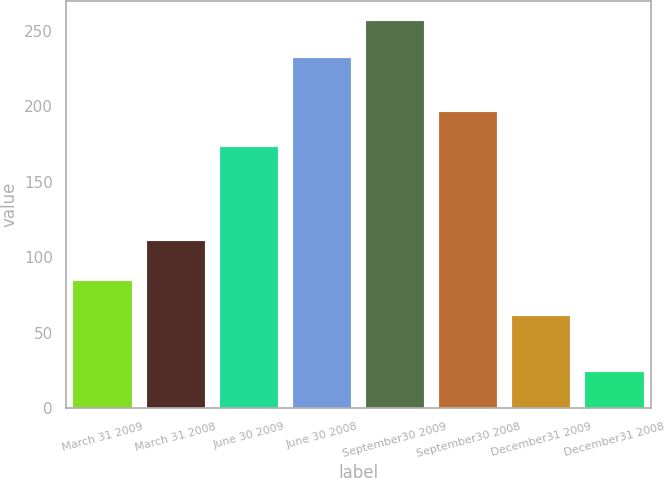Convert chart. <chart><loc_0><loc_0><loc_500><loc_500><bar_chart><fcel>March 31 2009<fcel>March 31 2008<fcel>June 30 2009<fcel>June 30 2008<fcel>September30 2009<fcel>September30 2008<fcel>December31 2009<fcel>December31 2008<nl><fcel>84.3<fcel>111<fcel>173<fcel>232<fcel>257<fcel>196.3<fcel>61<fcel>24<nl></chart> 